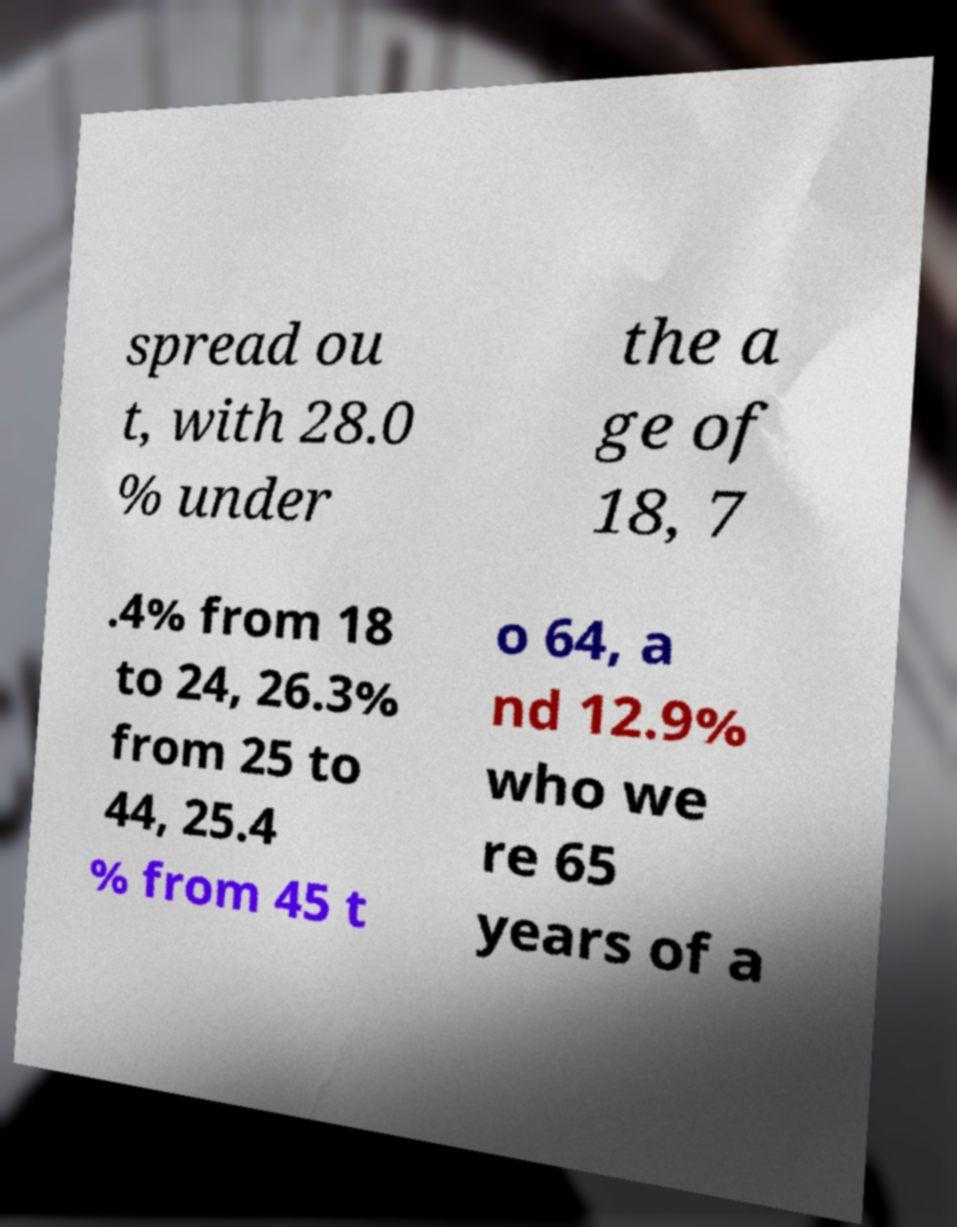Could you extract and type out the text from this image? spread ou t, with 28.0 % under the a ge of 18, 7 .4% from 18 to 24, 26.3% from 25 to 44, 25.4 % from 45 t o 64, a nd 12.9% who we re 65 years of a 